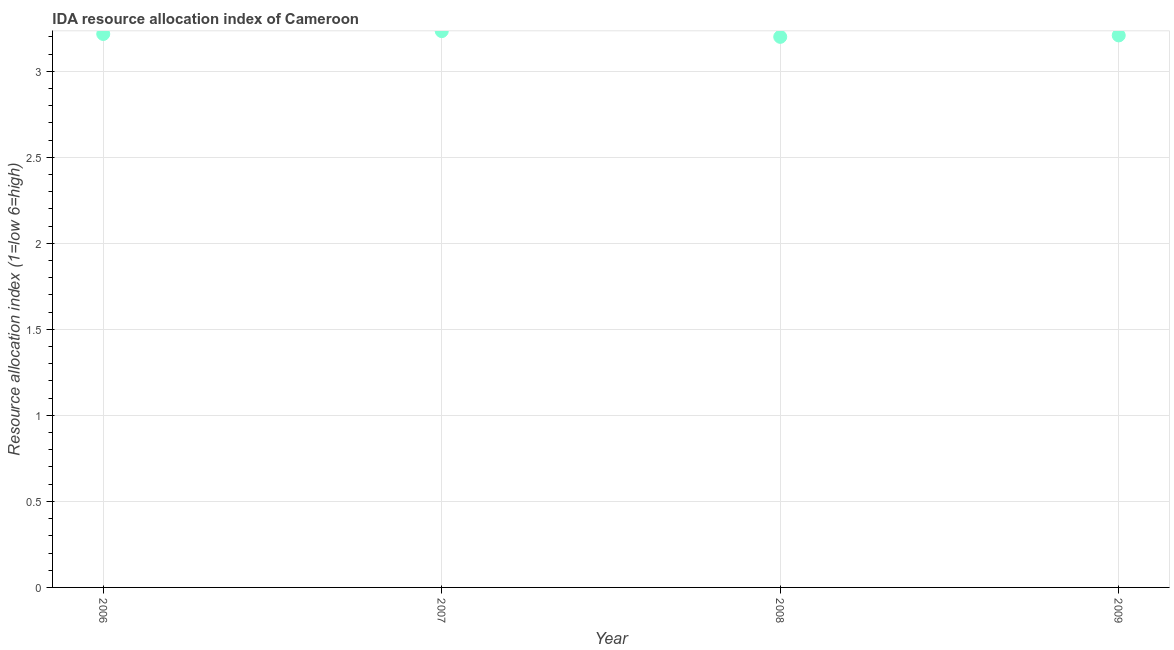What is the ida resource allocation index in 2008?
Offer a very short reply. 3.2. Across all years, what is the maximum ida resource allocation index?
Make the answer very short. 3.23. In which year was the ida resource allocation index maximum?
Your response must be concise. 2007. In which year was the ida resource allocation index minimum?
Offer a very short reply. 2008. What is the sum of the ida resource allocation index?
Provide a short and direct response. 12.86. What is the difference between the ida resource allocation index in 2008 and 2009?
Provide a succinct answer. -0.01. What is the average ida resource allocation index per year?
Offer a terse response. 3.21. What is the median ida resource allocation index?
Your answer should be very brief. 3.21. In how many years, is the ida resource allocation index greater than 0.9 ?
Your answer should be very brief. 4. Do a majority of the years between 2009 and 2007 (inclusive) have ida resource allocation index greater than 0.30000000000000004 ?
Provide a short and direct response. No. What is the ratio of the ida resource allocation index in 2007 to that in 2009?
Make the answer very short. 1.01. Is the ida resource allocation index in 2007 less than that in 2008?
Offer a very short reply. No. What is the difference between the highest and the second highest ida resource allocation index?
Give a very brief answer. 0.02. Is the sum of the ida resource allocation index in 2008 and 2009 greater than the maximum ida resource allocation index across all years?
Your answer should be compact. Yes. What is the difference between the highest and the lowest ida resource allocation index?
Provide a short and direct response. 0.03. How many dotlines are there?
Your answer should be compact. 1. How many years are there in the graph?
Your response must be concise. 4. Are the values on the major ticks of Y-axis written in scientific E-notation?
Your answer should be compact. No. Does the graph contain any zero values?
Provide a short and direct response. No. Does the graph contain grids?
Offer a very short reply. Yes. What is the title of the graph?
Provide a succinct answer. IDA resource allocation index of Cameroon. What is the label or title of the Y-axis?
Give a very brief answer. Resource allocation index (1=low 6=high). What is the Resource allocation index (1=low 6=high) in 2006?
Ensure brevity in your answer.  3.22. What is the Resource allocation index (1=low 6=high) in 2007?
Ensure brevity in your answer.  3.23. What is the Resource allocation index (1=low 6=high) in 2009?
Make the answer very short. 3.21. What is the difference between the Resource allocation index (1=low 6=high) in 2006 and 2007?
Offer a terse response. -0.02. What is the difference between the Resource allocation index (1=low 6=high) in 2006 and 2008?
Provide a succinct answer. 0.02. What is the difference between the Resource allocation index (1=low 6=high) in 2006 and 2009?
Make the answer very short. 0.01. What is the difference between the Resource allocation index (1=low 6=high) in 2007 and 2008?
Keep it short and to the point. 0.03. What is the difference between the Resource allocation index (1=low 6=high) in 2007 and 2009?
Offer a very short reply. 0.03. What is the difference between the Resource allocation index (1=low 6=high) in 2008 and 2009?
Make the answer very short. -0.01. What is the ratio of the Resource allocation index (1=low 6=high) in 2006 to that in 2007?
Your answer should be compact. 0.99. What is the ratio of the Resource allocation index (1=low 6=high) in 2006 to that in 2008?
Give a very brief answer. 1. What is the ratio of the Resource allocation index (1=low 6=high) in 2007 to that in 2008?
Ensure brevity in your answer.  1.01. 